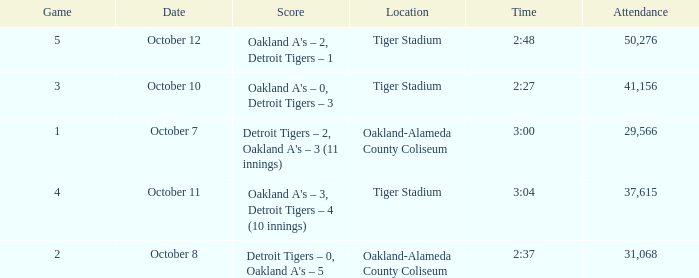What is the number of people in attendance at Oakland-Alameda County Coliseum, and game is 2? 31068.0. 